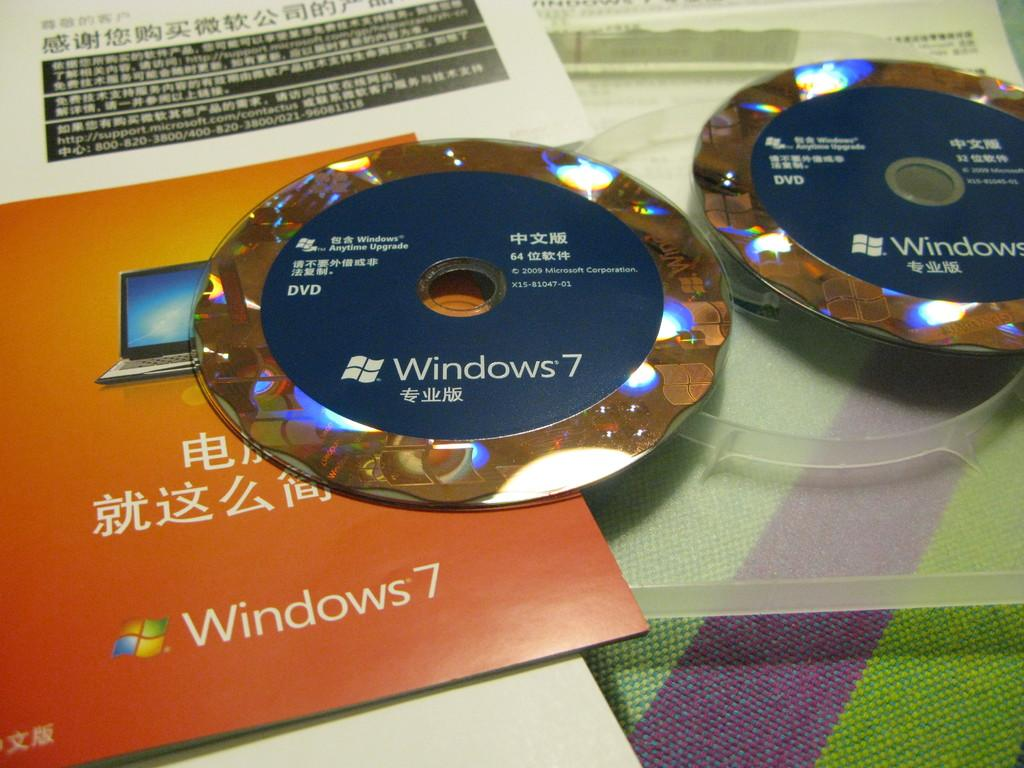<image>
Summarize the visual content of the image. two windows 7 installation DVDs are on the top of the manuals in Chinese. 